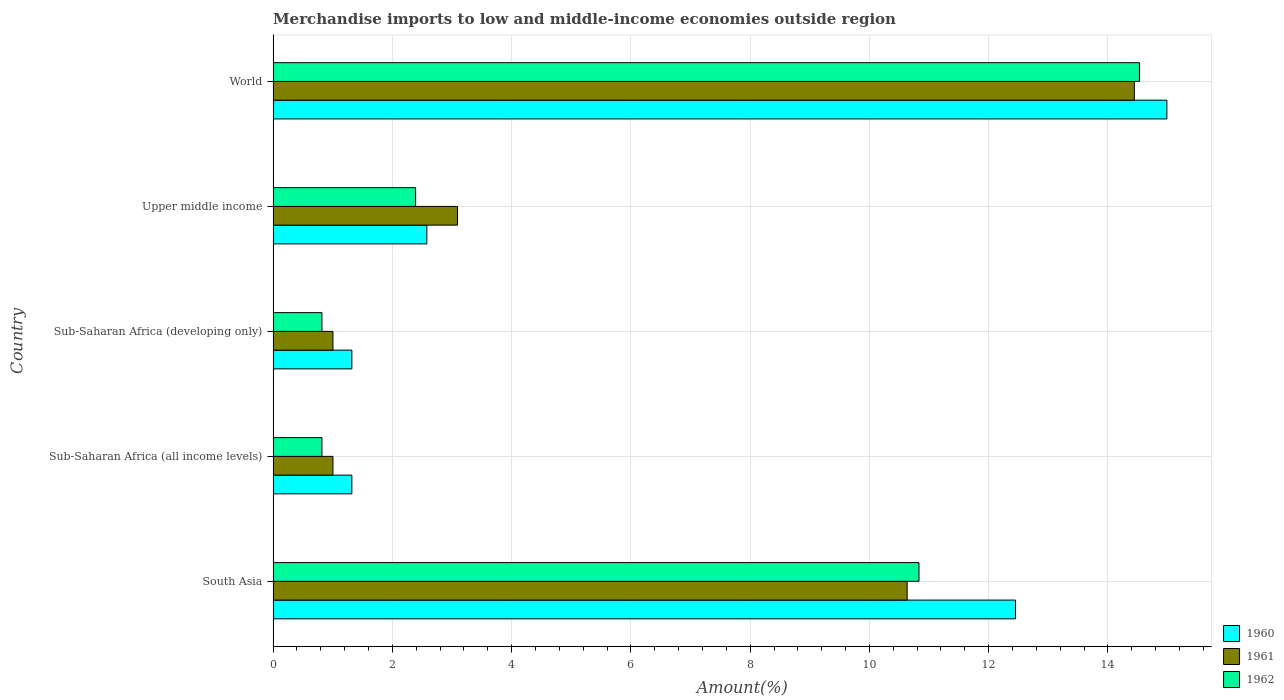Are the number of bars per tick equal to the number of legend labels?
Provide a succinct answer. Yes. Are the number of bars on each tick of the Y-axis equal?
Keep it short and to the point. Yes. How many bars are there on the 2nd tick from the top?
Keep it short and to the point. 3. What is the label of the 3rd group of bars from the top?
Offer a very short reply. Sub-Saharan Africa (developing only). In how many cases, is the number of bars for a given country not equal to the number of legend labels?
Provide a short and direct response. 0. What is the percentage of amount earned from merchandise imports in 1962 in Upper middle income?
Offer a terse response. 2.39. Across all countries, what is the maximum percentage of amount earned from merchandise imports in 1962?
Provide a short and direct response. 14.53. Across all countries, what is the minimum percentage of amount earned from merchandise imports in 1961?
Give a very brief answer. 1. In which country was the percentage of amount earned from merchandise imports in 1960 maximum?
Make the answer very short. World. In which country was the percentage of amount earned from merchandise imports in 1960 minimum?
Ensure brevity in your answer.  Sub-Saharan Africa (all income levels). What is the total percentage of amount earned from merchandise imports in 1961 in the graph?
Give a very brief answer. 30.18. What is the difference between the percentage of amount earned from merchandise imports in 1960 in South Asia and that in Upper middle income?
Keep it short and to the point. 9.87. What is the difference between the percentage of amount earned from merchandise imports in 1961 in Upper middle income and the percentage of amount earned from merchandise imports in 1962 in South Asia?
Your answer should be very brief. -7.74. What is the average percentage of amount earned from merchandise imports in 1961 per country?
Your answer should be compact. 6.04. What is the difference between the percentage of amount earned from merchandise imports in 1961 and percentage of amount earned from merchandise imports in 1960 in Sub-Saharan Africa (all income levels)?
Your answer should be very brief. -0.32. What is the ratio of the percentage of amount earned from merchandise imports in 1962 in Sub-Saharan Africa (developing only) to that in World?
Give a very brief answer. 0.06. Is the difference between the percentage of amount earned from merchandise imports in 1961 in South Asia and Upper middle income greater than the difference between the percentage of amount earned from merchandise imports in 1960 in South Asia and Upper middle income?
Your answer should be compact. No. What is the difference between the highest and the second highest percentage of amount earned from merchandise imports in 1961?
Your answer should be compact. 3.81. What is the difference between the highest and the lowest percentage of amount earned from merchandise imports in 1962?
Provide a short and direct response. 13.71. What does the 3rd bar from the top in Sub-Saharan Africa (developing only) represents?
Your answer should be very brief. 1960. What does the 3rd bar from the bottom in South Asia represents?
Make the answer very short. 1962. What is the difference between two consecutive major ticks on the X-axis?
Make the answer very short. 2. Does the graph contain any zero values?
Ensure brevity in your answer.  No. Where does the legend appear in the graph?
Provide a succinct answer. Bottom right. How many legend labels are there?
Provide a short and direct response. 3. What is the title of the graph?
Offer a very short reply. Merchandise imports to low and middle-income economies outside region. Does "2001" appear as one of the legend labels in the graph?
Give a very brief answer. No. What is the label or title of the X-axis?
Your answer should be very brief. Amount(%). What is the label or title of the Y-axis?
Your response must be concise. Country. What is the Amount(%) of 1960 in South Asia?
Provide a short and direct response. 12.45. What is the Amount(%) in 1961 in South Asia?
Keep it short and to the point. 10.63. What is the Amount(%) of 1962 in South Asia?
Your answer should be compact. 10.83. What is the Amount(%) in 1960 in Sub-Saharan Africa (all income levels)?
Make the answer very short. 1.32. What is the Amount(%) of 1961 in Sub-Saharan Africa (all income levels)?
Give a very brief answer. 1. What is the Amount(%) in 1962 in Sub-Saharan Africa (all income levels)?
Make the answer very short. 0.82. What is the Amount(%) of 1960 in Sub-Saharan Africa (developing only)?
Ensure brevity in your answer.  1.32. What is the Amount(%) in 1961 in Sub-Saharan Africa (developing only)?
Your response must be concise. 1. What is the Amount(%) in 1962 in Sub-Saharan Africa (developing only)?
Your answer should be compact. 0.82. What is the Amount(%) of 1960 in Upper middle income?
Ensure brevity in your answer.  2.58. What is the Amount(%) in 1961 in Upper middle income?
Provide a short and direct response. 3.09. What is the Amount(%) in 1962 in Upper middle income?
Keep it short and to the point. 2.39. What is the Amount(%) of 1960 in World?
Make the answer very short. 14.99. What is the Amount(%) in 1961 in World?
Provide a short and direct response. 14.44. What is the Amount(%) in 1962 in World?
Your answer should be compact. 14.53. Across all countries, what is the maximum Amount(%) of 1960?
Make the answer very short. 14.99. Across all countries, what is the maximum Amount(%) in 1961?
Ensure brevity in your answer.  14.44. Across all countries, what is the maximum Amount(%) of 1962?
Give a very brief answer. 14.53. Across all countries, what is the minimum Amount(%) in 1960?
Make the answer very short. 1.32. Across all countries, what is the minimum Amount(%) in 1961?
Keep it short and to the point. 1. Across all countries, what is the minimum Amount(%) of 1962?
Keep it short and to the point. 0.82. What is the total Amount(%) of 1960 in the graph?
Make the answer very short. 32.66. What is the total Amount(%) of 1961 in the graph?
Your answer should be compact. 30.18. What is the total Amount(%) in 1962 in the graph?
Offer a terse response. 29.39. What is the difference between the Amount(%) of 1960 in South Asia and that in Sub-Saharan Africa (all income levels)?
Your response must be concise. 11.13. What is the difference between the Amount(%) of 1961 in South Asia and that in Sub-Saharan Africa (all income levels)?
Ensure brevity in your answer.  9.63. What is the difference between the Amount(%) of 1962 in South Asia and that in Sub-Saharan Africa (all income levels)?
Your answer should be very brief. 10.01. What is the difference between the Amount(%) in 1960 in South Asia and that in Sub-Saharan Africa (developing only)?
Your response must be concise. 11.13. What is the difference between the Amount(%) in 1961 in South Asia and that in Sub-Saharan Africa (developing only)?
Keep it short and to the point. 9.63. What is the difference between the Amount(%) of 1962 in South Asia and that in Sub-Saharan Africa (developing only)?
Keep it short and to the point. 10.01. What is the difference between the Amount(%) of 1960 in South Asia and that in Upper middle income?
Provide a succinct answer. 9.87. What is the difference between the Amount(%) in 1961 in South Asia and that in Upper middle income?
Make the answer very short. 7.54. What is the difference between the Amount(%) of 1962 in South Asia and that in Upper middle income?
Ensure brevity in your answer.  8.44. What is the difference between the Amount(%) of 1960 in South Asia and that in World?
Your answer should be very brief. -2.54. What is the difference between the Amount(%) of 1961 in South Asia and that in World?
Give a very brief answer. -3.81. What is the difference between the Amount(%) in 1962 in South Asia and that in World?
Keep it short and to the point. -3.7. What is the difference between the Amount(%) in 1960 in Sub-Saharan Africa (all income levels) and that in Sub-Saharan Africa (developing only)?
Your answer should be compact. 0. What is the difference between the Amount(%) in 1960 in Sub-Saharan Africa (all income levels) and that in Upper middle income?
Offer a very short reply. -1.26. What is the difference between the Amount(%) of 1961 in Sub-Saharan Africa (all income levels) and that in Upper middle income?
Your answer should be very brief. -2.09. What is the difference between the Amount(%) in 1962 in Sub-Saharan Africa (all income levels) and that in Upper middle income?
Give a very brief answer. -1.57. What is the difference between the Amount(%) of 1960 in Sub-Saharan Africa (all income levels) and that in World?
Your answer should be very brief. -13.67. What is the difference between the Amount(%) of 1961 in Sub-Saharan Africa (all income levels) and that in World?
Ensure brevity in your answer.  -13.44. What is the difference between the Amount(%) in 1962 in Sub-Saharan Africa (all income levels) and that in World?
Keep it short and to the point. -13.71. What is the difference between the Amount(%) in 1960 in Sub-Saharan Africa (developing only) and that in Upper middle income?
Keep it short and to the point. -1.26. What is the difference between the Amount(%) in 1961 in Sub-Saharan Africa (developing only) and that in Upper middle income?
Provide a short and direct response. -2.09. What is the difference between the Amount(%) of 1962 in Sub-Saharan Africa (developing only) and that in Upper middle income?
Ensure brevity in your answer.  -1.57. What is the difference between the Amount(%) of 1960 in Sub-Saharan Africa (developing only) and that in World?
Your answer should be very brief. -13.67. What is the difference between the Amount(%) of 1961 in Sub-Saharan Africa (developing only) and that in World?
Provide a short and direct response. -13.44. What is the difference between the Amount(%) of 1962 in Sub-Saharan Africa (developing only) and that in World?
Provide a succinct answer. -13.71. What is the difference between the Amount(%) in 1960 in Upper middle income and that in World?
Ensure brevity in your answer.  -12.41. What is the difference between the Amount(%) of 1961 in Upper middle income and that in World?
Offer a very short reply. -11.35. What is the difference between the Amount(%) of 1962 in Upper middle income and that in World?
Provide a short and direct response. -12.14. What is the difference between the Amount(%) in 1960 in South Asia and the Amount(%) in 1961 in Sub-Saharan Africa (all income levels)?
Your answer should be compact. 11.45. What is the difference between the Amount(%) in 1960 in South Asia and the Amount(%) in 1962 in Sub-Saharan Africa (all income levels)?
Provide a short and direct response. 11.63. What is the difference between the Amount(%) of 1961 in South Asia and the Amount(%) of 1962 in Sub-Saharan Africa (all income levels)?
Make the answer very short. 9.81. What is the difference between the Amount(%) of 1960 in South Asia and the Amount(%) of 1961 in Sub-Saharan Africa (developing only)?
Your response must be concise. 11.45. What is the difference between the Amount(%) of 1960 in South Asia and the Amount(%) of 1962 in Sub-Saharan Africa (developing only)?
Provide a succinct answer. 11.63. What is the difference between the Amount(%) in 1961 in South Asia and the Amount(%) in 1962 in Sub-Saharan Africa (developing only)?
Offer a terse response. 9.81. What is the difference between the Amount(%) in 1960 in South Asia and the Amount(%) in 1961 in Upper middle income?
Keep it short and to the point. 9.36. What is the difference between the Amount(%) of 1960 in South Asia and the Amount(%) of 1962 in Upper middle income?
Your answer should be compact. 10.06. What is the difference between the Amount(%) of 1961 in South Asia and the Amount(%) of 1962 in Upper middle income?
Offer a terse response. 8.24. What is the difference between the Amount(%) in 1960 in South Asia and the Amount(%) in 1961 in World?
Keep it short and to the point. -1.99. What is the difference between the Amount(%) in 1960 in South Asia and the Amount(%) in 1962 in World?
Your answer should be compact. -2.08. What is the difference between the Amount(%) in 1961 in South Asia and the Amount(%) in 1962 in World?
Provide a succinct answer. -3.9. What is the difference between the Amount(%) of 1960 in Sub-Saharan Africa (all income levels) and the Amount(%) of 1961 in Sub-Saharan Africa (developing only)?
Give a very brief answer. 0.32. What is the difference between the Amount(%) of 1960 in Sub-Saharan Africa (all income levels) and the Amount(%) of 1962 in Sub-Saharan Africa (developing only)?
Offer a terse response. 0.5. What is the difference between the Amount(%) in 1961 in Sub-Saharan Africa (all income levels) and the Amount(%) in 1962 in Sub-Saharan Africa (developing only)?
Give a very brief answer. 0.18. What is the difference between the Amount(%) in 1960 in Sub-Saharan Africa (all income levels) and the Amount(%) in 1961 in Upper middle income?
Keep it short and to the point. -1.77. What is the difference between the Amount(%) in 1960 in Sub-Saharan Africa (all income levels) and the Amount(%) in 1962 in Upper middle income?
Your answer should be compact. -1.07. What is the difference between the Amount(%) of 1961 in Sub-Saharan Africa (all income levels) and the Amount(%) of 1962 in Upper middle income?
Make the answer very short. -1.39. What is the difference between the Amount(%) in 1960 in Sub-Saharan Africa (all income levels) and the Amount(%) in 1961 in World?
Your response must be concise. -13.12. What is the difference between the Amount(%) of 1960 in Sub-Saharan Africa (all income levels) and the Amount(%) of 1962 in World?
Your response must be concise. -13.21. What is the difference between the Amount(%) in 1961 in Sub-Saharan Africa (all income levels) and the Amount(%) in 1962 in World?
Give a very brief answer. -13.53. What is the difference between the Amount(%) in 1960 in Sub-Saharan Africa (developing only) and the Amount(%) in 1961 in Upper middle income?
Give a very brief answer. -1.77. What is the difference between the Amount(%) in 1960 in Sub-Saharan Africa (developing only) and the Amount(%) in 1962 in Upper middle income?
Offer a very short reply. -1.07. What is the difference between the Amount(%) in 1961 in Sub-Saharan Africa (developing only) and the Amount(%) in 1962 in Upper middle income?
Ensure brevity in your answer.  -1.39. What is the difference between the Amount(%) of 1960 in Sub-Saharan Africa (developing only) and the Amount(%) of 1961 in World?
Ensure brevity in your answer.  -13.12. What is the difference between the Amount(%) in 1960 in Sub-Saharan Africa (developing only) and the Amount(%) in 1962 in World?
Give a very brief answer. -13.21. What is the difference between the Amount(%) of 1961 in Sub-Saharan Africa (developing only) and the Amount(%) of 1962 in World?
Your answer should be very brief. -13.53. What is the difference between the Amount(%) of 1960 in Upper middle income and the Amount(%) of 1961 in World?
Your answer should be compact. -11.86. What is the difference between the Amount(%) of 1960 in Upper middle income and the Amount(%) of 1962 in World?
Keep it short and to the point. -11.95. What is the difference between the Amount(%) in 1961 in Upper middle income and the Amount(%) in 1962 in World?
Provide a succinct answer. -11.44. What is the average Amount(%) in 1960 per country?
Make the answer very short. 6.53. What is the average Amount(%) of 1961 per country?
Provide a short and direct response. 6.04. What is the average Amount(%) in 1962 per country?
Keep it short and to the point. 5.88. What is the difference between the Amount(%) of 1960 and Amount(%) of 1961 in South Asia?
Your response must be concise. 1.82. What is the difference between the Amount(%) of 1960 and Amount(%) of 1962 in South Asia?
Offer a terse response. 1.62. What is the difference between the Amount(%) in 1961 and Amount(%) in 1962 in South Asia?
Keep it short and to the point. -0.2. What is the difference between the Amount(%) in 1960 and Amount(%) in 1961 in Sub-Saharan Africa (all income levels)?
Offer a terse response. 0.32. What is the difference between the Amount(%) in 1960 and Amount(%) in 1962 in Sub-Saharan Africa (all income levels)?
Provide a succinct answer. 0.5. What is the difference between the Amount(%) of 1961 and Amount(%) of 1962 in Sub-Saharan Africa (all income levels)?
Give a very brief answer. 0.18. What is the difference between the Amount(%) in 1960 and Amount(%) in 1961 in Sub-Saharan Africa (developing only)?
Your answer should be very brief. 0.32. What is the difference between the Amount(%) in 1960 and Amount(%) in 1962 in Sub-Saharan Africa (developing only)?
Offer a very short reply. 0.5. What is the difference between the Amount(%) of 1961 and Amount(%) of 1962 in Sub-Saharan Africa (developing only)?
Keep it short and to the point. 0.18. What is the difference between the Amount(%) of 1960 and Amount(%) of 1961 in Upper middle income?
Give a very brief answer. -0.51. What is the difference between the Amount(%) of 1960 and Amount(%) of 1962 in Upper middle income?
Offer a terse response. 0.19. What is the difference between the Amount(%) in 1961 and Amount(%) in 1962 in Upper middle income?
Ensure brevity in your answer.  0.7. What is the difference between the Amount(%) of 1960 and Amount(%) of 1961 in World?
Give a very brief answer. 0.55. What is the difference between the Amount(%) of 1960 and Amount(%) of 1962 in World?
Provide a short and direct response. 0.46. What is the difference between the Amount(%) of 1961 and Amount(%) of 1962 in World?
Offer a terse response. -0.09. What is the ratio of the Amount(%) of 1960 in South Asia to that in Sub-Saharan Africa (all income levels)?
Your answer should be compact. 9.43. What is the ratio of the Amount(%) in 1961 in South Asia to that in Sub-Saharan Africa (all income levels)?
Keep it short and to the point. 10.59. What is the ratio of the Amount(%) of 1962 in South Asia to that in Sub-Saharan Africa (all income levels)?
Give a very brief answer. 13.23. What is the ratio of the Amount(%) of 1960 in South Asia to that in Sub-Saharan Africa (developing only)?
Provide a succinct answer. 9.43. What is the ratio of the Amount(%) of 1961 in South Asia to that in Sub-Saharan Africa (developing only)?
Your answer should be compact. 10.59. What is the ratio of the Amount(%) of 1962 in South Asia to that in Sub-Saharan Africa (developing only)?
Provide a succinct answer. 13.23. What is the ratio of the Amount(%) in 1960 in South Asia to that in Upper middle income?
Your answer should be compact. 4.83. What is the ratio of the Amount(%) in 1961 in South Asia to that in Upper middle income?
Your response must be concise. 3.44. What is the ratio of the Amount(%) of 1962 in South Asia to that in Upper middle income?
Provide a succinct answer. 4.53. What is the ratio of the Amount(%) of 1960 in South Asia to that in World?
Give a very brief answer. 0.83. What is the ratio of the Amount(%) in 1961 in South Asia to that in World?
Give a very brief answer. 0.74. What is the ratio of the Amount(%) in 1962 in South Asia to that in World?
Ensure brevity in your answer.  0.75. What is the ratio of the Amount(%) of 1960 in Sub-Saharan Africa (all income levels) to that in Sub-Saharan Africa (developing only)?
Provide a short and direct response. 1. What is the ratio of the Amount(%) in 1961 in Sub-Saharan Africa (all income levels) to that in Sub-Saharan Africa (developing only)?
Your answer should be very brief. 1. What is the ratio of the Amount(%) of 1962 in Sub-Saharan Africa (all income levels) to that in Sub-Saharan Africa (developing only)?
Your response must be concise. 1. What is the ratio of the Amount(%) of 1960 in Sub-Saharan Africa (all income levels) to that in Upper middle income?
Ensure brevity in your answer.  0.51. What is the ratio of the Amount(%) in 1961 in Sub-Saharan Africa (all income levels) to that in Upper middle income?
Your response must be concise. 0.32. What is the ratio of the Amount(%) of 1962 in Sub-Saharan Africa (all income levels) to that in Upper middle income?
Ensure brevity in your answer.  0.34. What is the ratio of the Amount(%) of 1960 in Sub-Saharan Africa (all income levels) to that in World?
Provide a short and direct response. 0.09. What is the ratio of the Amount(%) of 1961 in Sub-Saharan Africa (all income levels) to that in World?
Ensure brevity in your answer.  0.07. What is the ratio of the Amount(%) of 1962 in Sub-Saharan Africa (all income levels) to that in World?
Offer a very short reply. 0.06. What is the ratio of the Amount(%) of 1960 in Sub-Saharan Africa (developing only) to that in Upper middle income?
Make the answer very short. 0.51. What is the ratio of the Amount(%) of 1961 in Sub-Saharan Africa (developing only) to that in Upper middle income?
Ensure brevity in your answer.  0.32. What is the ratio of the Amount(%) of 1962 in Sub-Saharan Africa (developing only) to that in Upper middle income?
Make the answer very short. 0.34. What is the ratio of the Amount(%) of 1960 in Sub-Saharan Africa (developing only) to that in World?
Keep it short and to the point. 0.09. What is the ratio of the Amount(%) of 1961 in Sub-Saharan Africa (developing only) to that in World?
Offer a terse response. 0.07. What is the ratio of the Amount(%) in 1962 in Sub-Saharan Africa (developing only) to that in World?
Provide a succinct answer. 0.06. What is the ratio of the Amount(%) in 1960 in Upper middle income to that in World?
Give a very brief answer. 0.17. What is the ratio of the Amount(%) in 1961 in Upper middle income to that in World?
Make the answer very short. 0.21. What is the ratio of the Amount(%) of 1962 in Upper middle income to that in World?
Keep it short and to the point. 0.16. What is the difference between the highest and the second highest Amount(%) of 1960?
Offer a very short reply. 2.54. What is the difference between the highest and the second highest Amount(%) in 1961?
Offer a terse response. 3.81. What is the difference between the highest and the second highest Amount(%) of 1962?
Provide a succinct answer. 3.7. What is the difference between the highest and the lowest Amount(%) in 1960?
Offer a terse response. 13.67. What is the difference between the highest and the lowest Amount(%) in 1961?
Offer a terse response. 13.44. What is the difference between the highest and the lowest Amount(%) in 1962?
Provide a short and direct response. 13.71. 